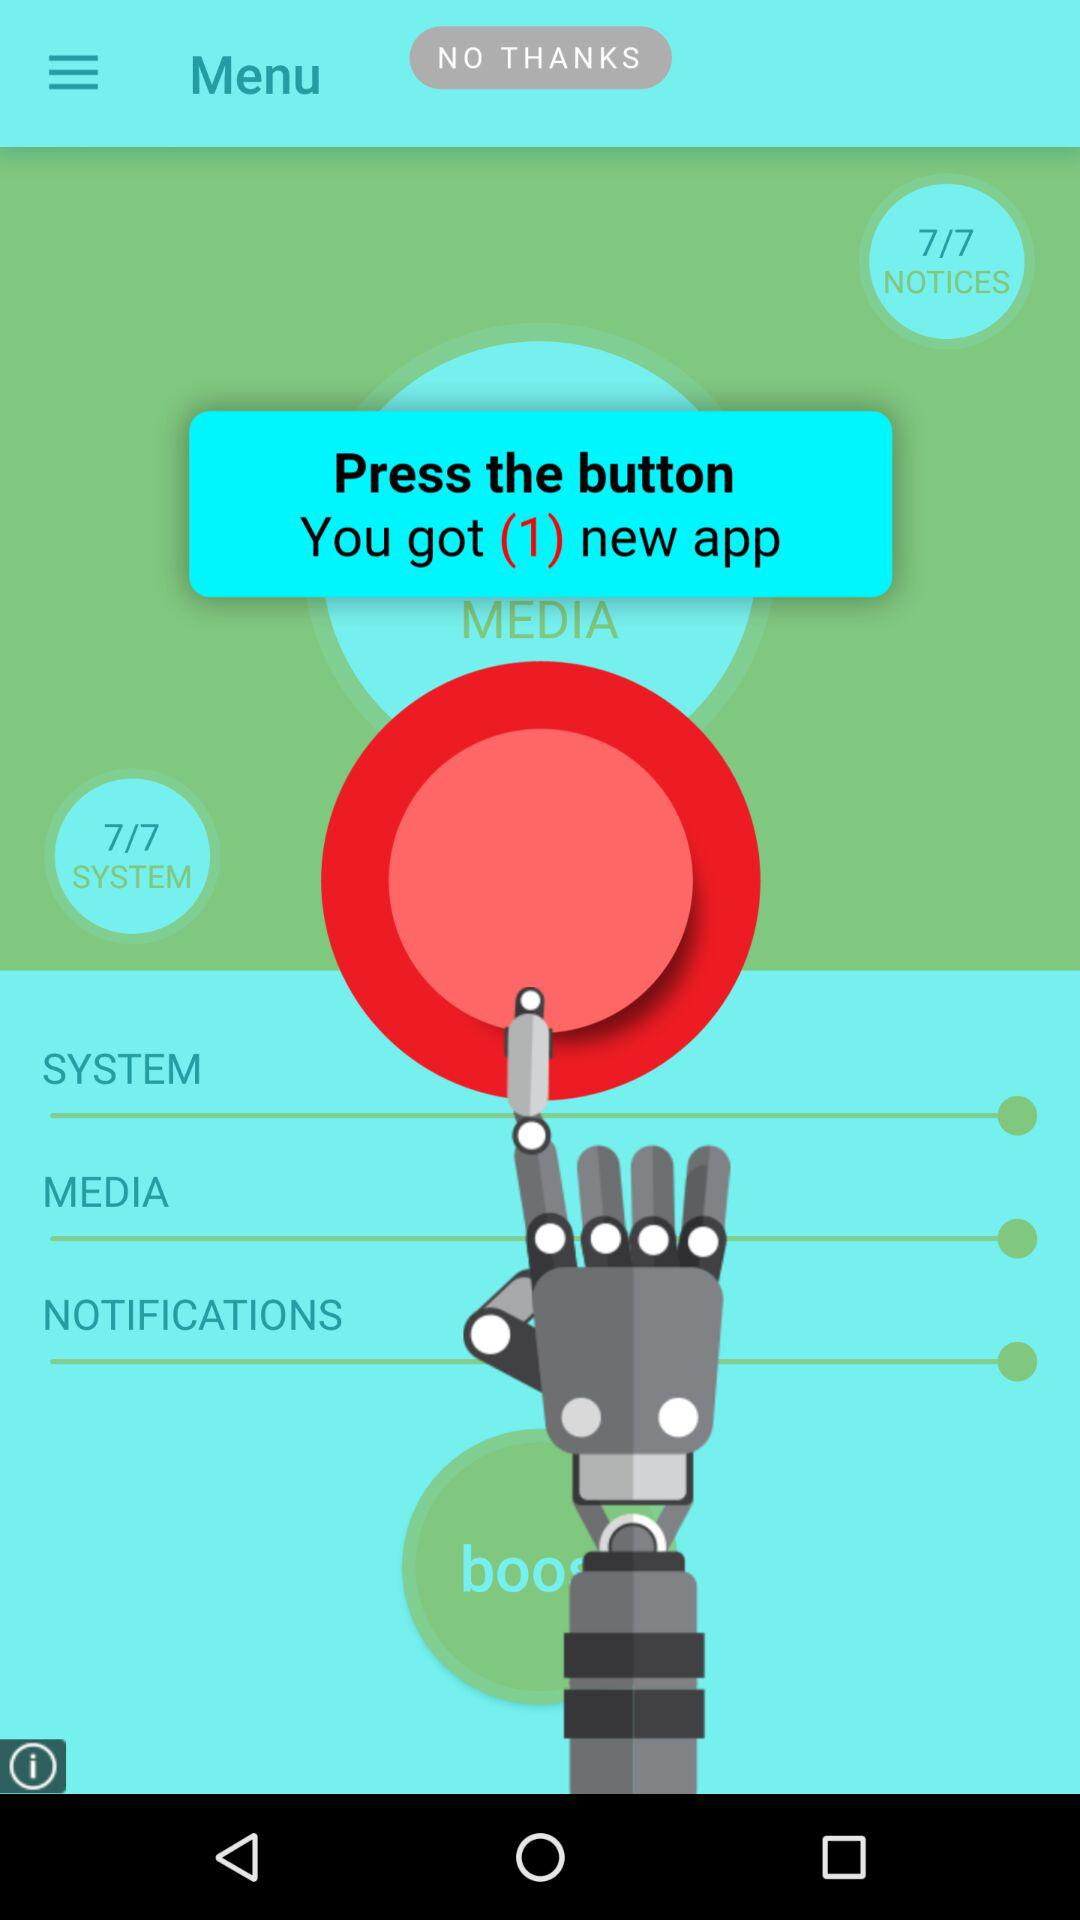How many systems are there? There are 7 systems. 